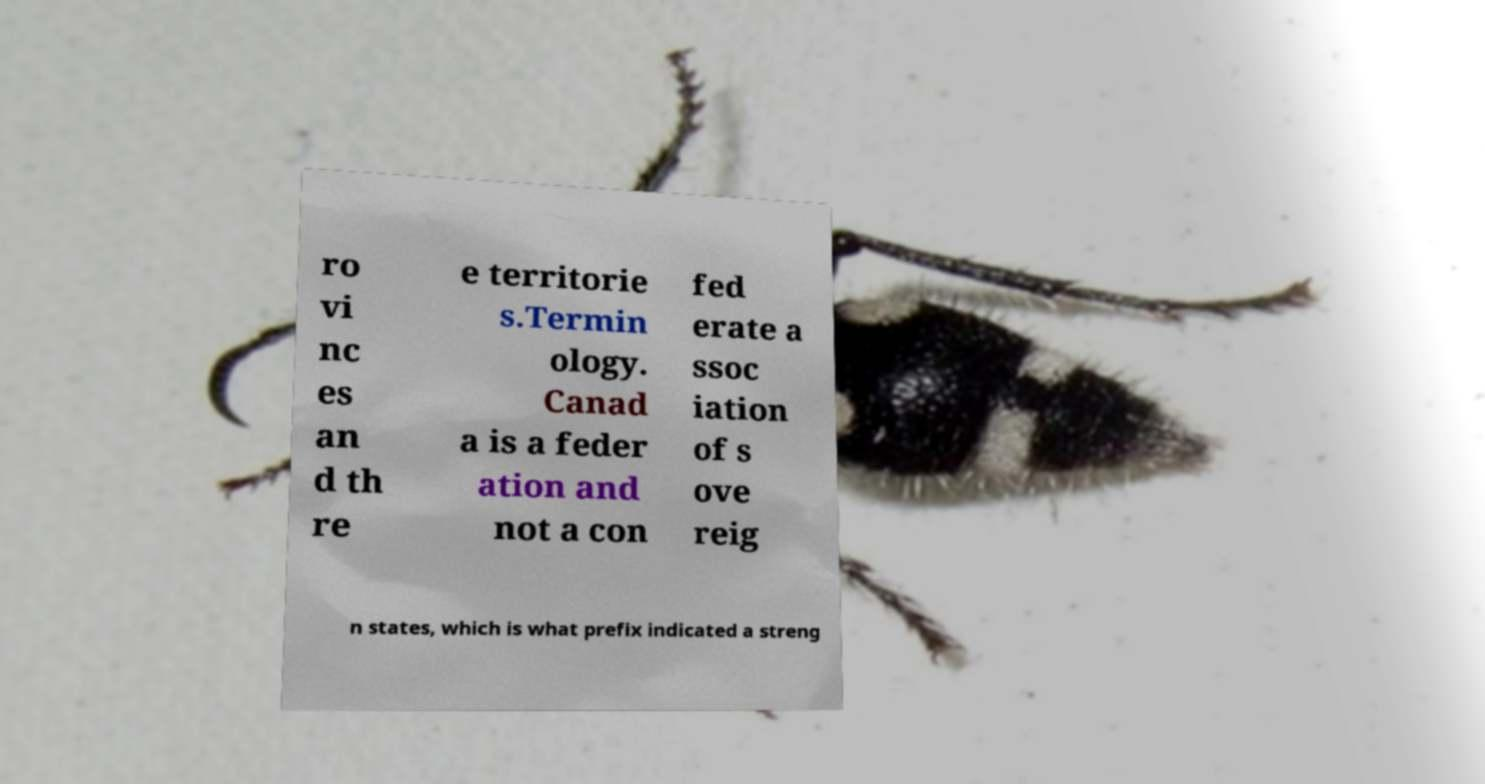For documentation purposes, I need the text within this image transcribed. Could you provide that? ro vi nc es an d th re e territorie s.Termin ology. Canad a is a feder ation and not a con fed erate a ssoc iation of s ove reig n states, which is what prefix indicated a streng 